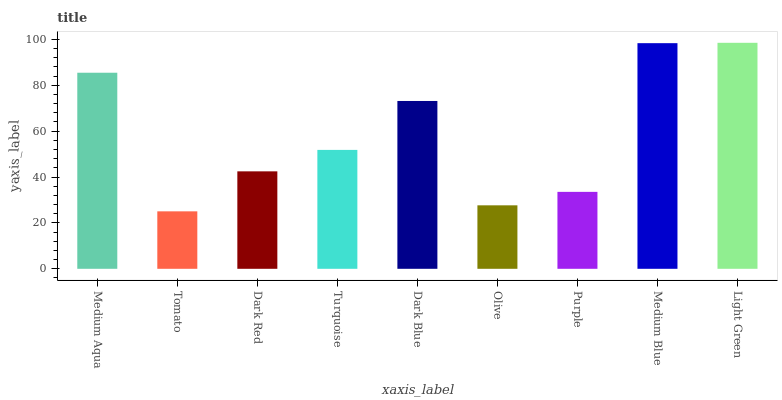Is Tomato the minimum?
Answer yes or no. Yes. Is Light Green the maximum?
Answer yes or no. Yes. Is Dark Red the minimum?
Answer yes or no. No. Is Dark Red the maximum?
Answer yes or no. No. Is Dark Red greater than Tomato?
Answer yes or no. Yes. Is Tomato less than Dark Red?
Answer yes or no. Yes. Is Tomato greater than Dark Red?
Answer yes or no. No. Is Dark Red less than Tomato?
Answer yes or no. No. Is Turquoise the high median?
Answer yes or no. Yes. Is Turquoise the low median?
Answer yes or no. Yes. Is Medium Aqua the high median?
Answer yes or no. No. Is Purple the low median?
Answer yes or no. No. 